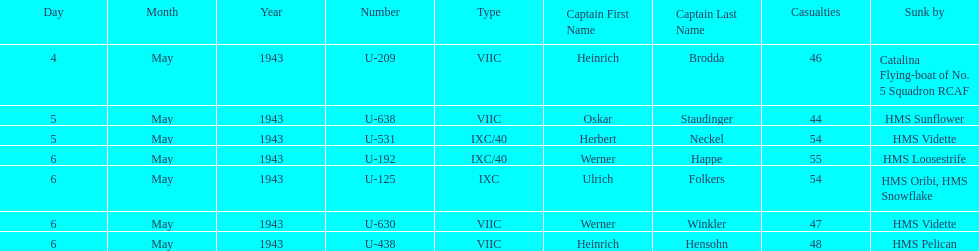What is the only vessel to sink multiple u-boats? HMS Vidette. 